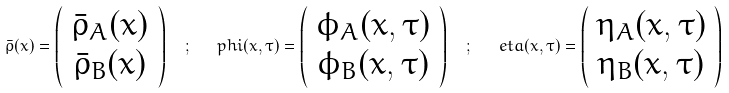Convert formula to latex. <formula><loc_0><loc_0><loc_500><loc_500>\bar { \rho } ( x ) = \left ( \begin{array} { c } \bar { \rho } _ { A } ( x ) \\ \bar { \rho } _ { B } ( x ) \end{array} \right ) \ \ ; \ \ \ p h i ( x , \tau ) = \left ( \begin{array} { c } \phi _ { A } ( x , \tau ) \\ \phi _ { B } ( x , \tau ) \end{array} \right ) \ \ ; \ \ \ e t a ( x , \tau ) = \left ( \begin{array} { c } \eta _ { A } ( x , \tau ) \\ \eta _ { B } ( x , \tau ) \end{array} \right )</formula> 